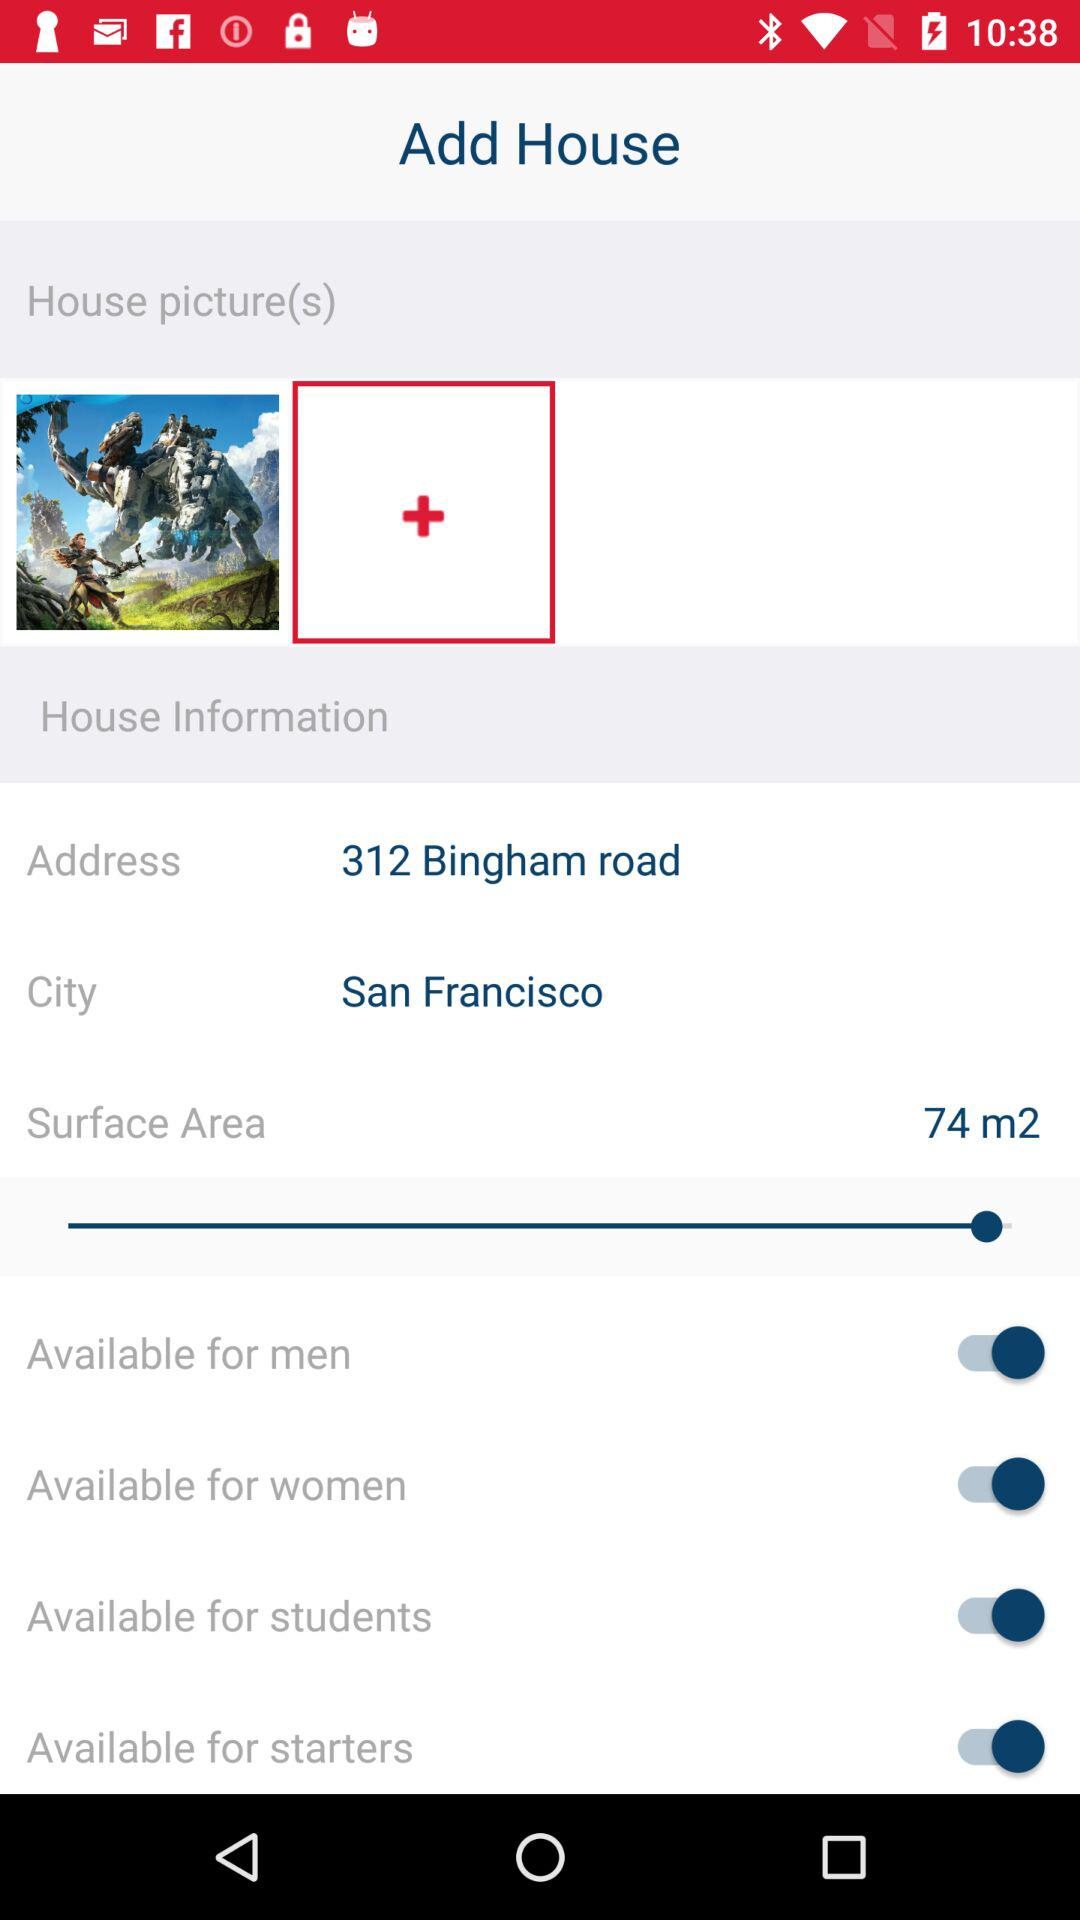What is the address? The address is 312 Bingham Road, San Francisco. 